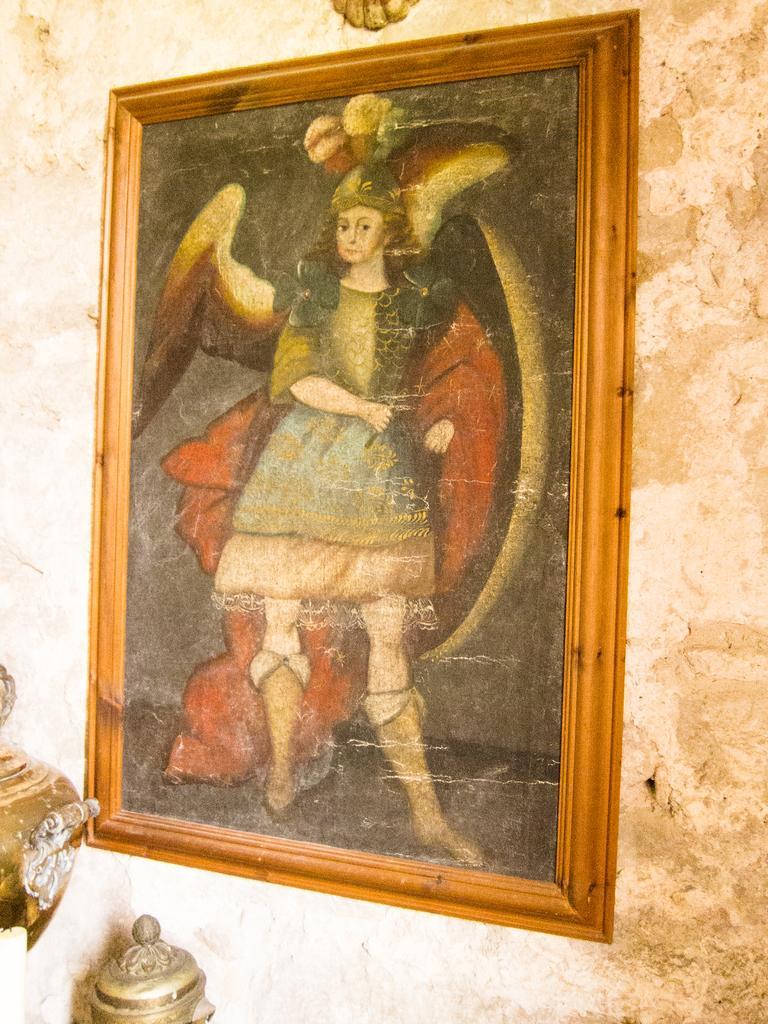Describe this image in one or two sentences. This picture contains photo frame of the woman who is wearing a green dress. This photo frame is placed on the white wall. At the bottom of the picture, we see a pole and something in brown color. 